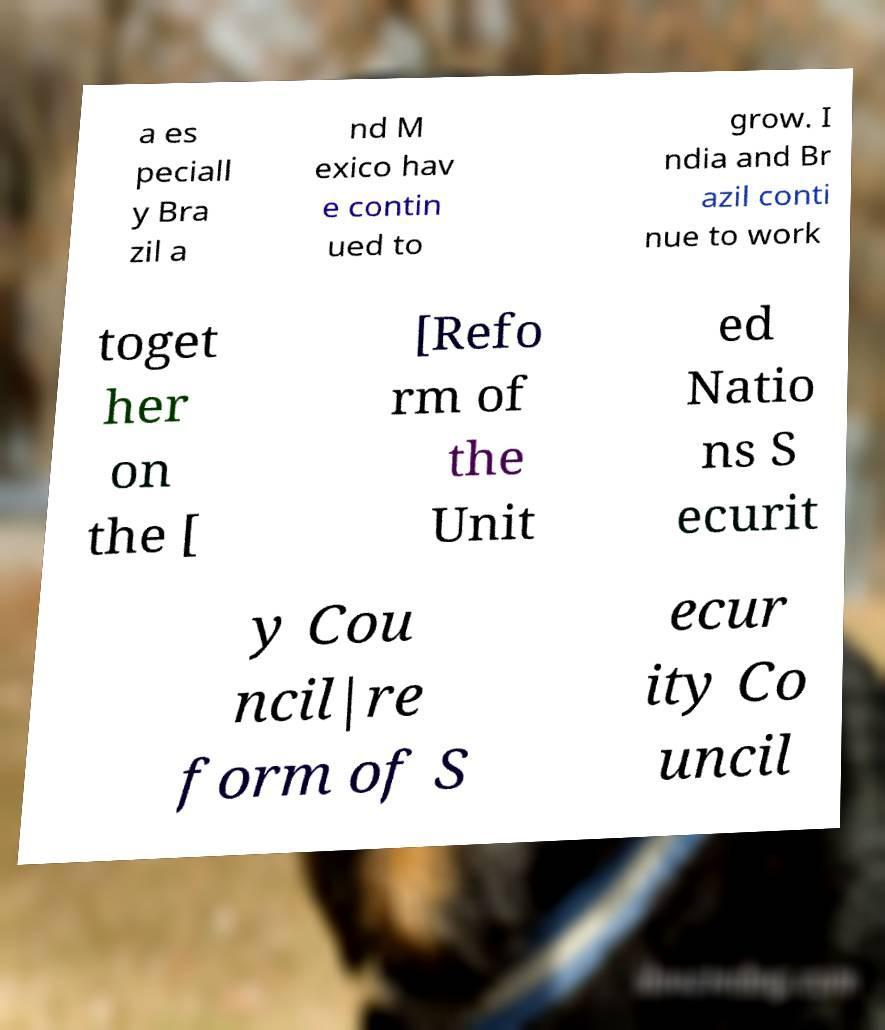Could you assist in decoding the text presented in this image and type it out clearly? a es peciall y Bra zil a nd M exico hav e contin ued to grow. I ndia and Br azil conti nue to work toget her on the [ [Refo rm of the Unit ed Natio ns S ecurit y Cou ncil|re form of S ecur ity Co uncil 